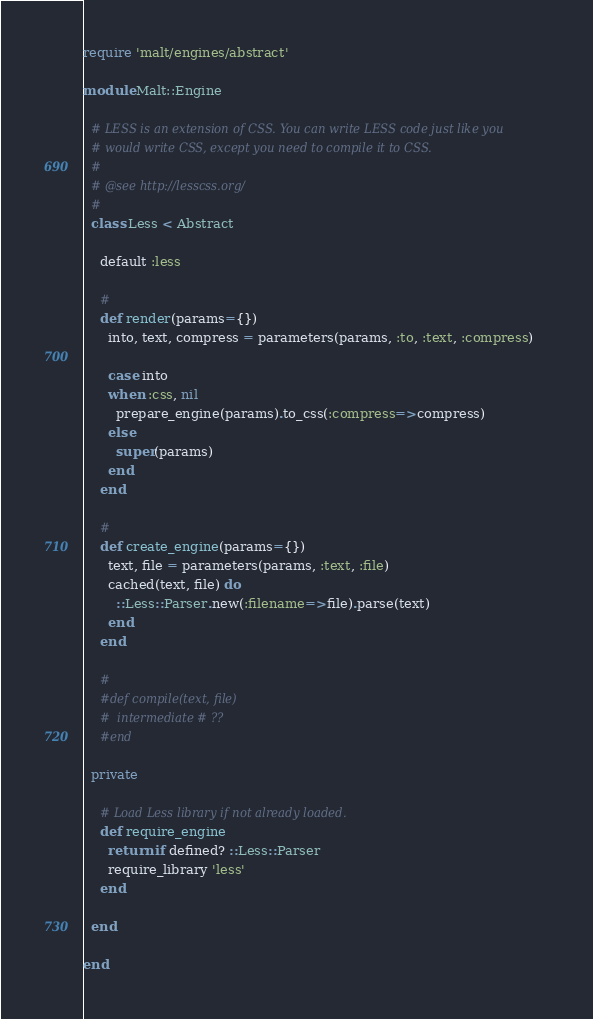Convert code to text. <code><loc_0><loc_0><loc_500><loc_500><_Ruby_>require 'malt/engines/abstract'

module Malt::Engine

  # LESS is an extension of CSS. You can write LESS code just like you
  # would write CSS, except you need to compile it to CSS.
  #
  # @see http://lesscss.org/
  #
  class Less < Abstract

    default :less

    #
    def render(params={})
      into, text, compress = parameters(params, :to, :text, :compress)

      case into
      when :css, nil
        prepare_engine(params).to_css(:compress=>compress)
      else
        super(params)
      end
    end

    #
    def create_engine(params={})
      text, file = parameters(params, :text, :file)
      cached(text, file) do
        ::Less::Parser.new(:filename=>file).parse(text)
      end
    end

    #
    #def compile(text, file)
    #  intermediate # ??
    #end

  private

    # Load Less library if not already loaded.
    def require_engine
      return if defined? ::Less::Parser
      require_library 'less'
    end

  end

end

</code> 